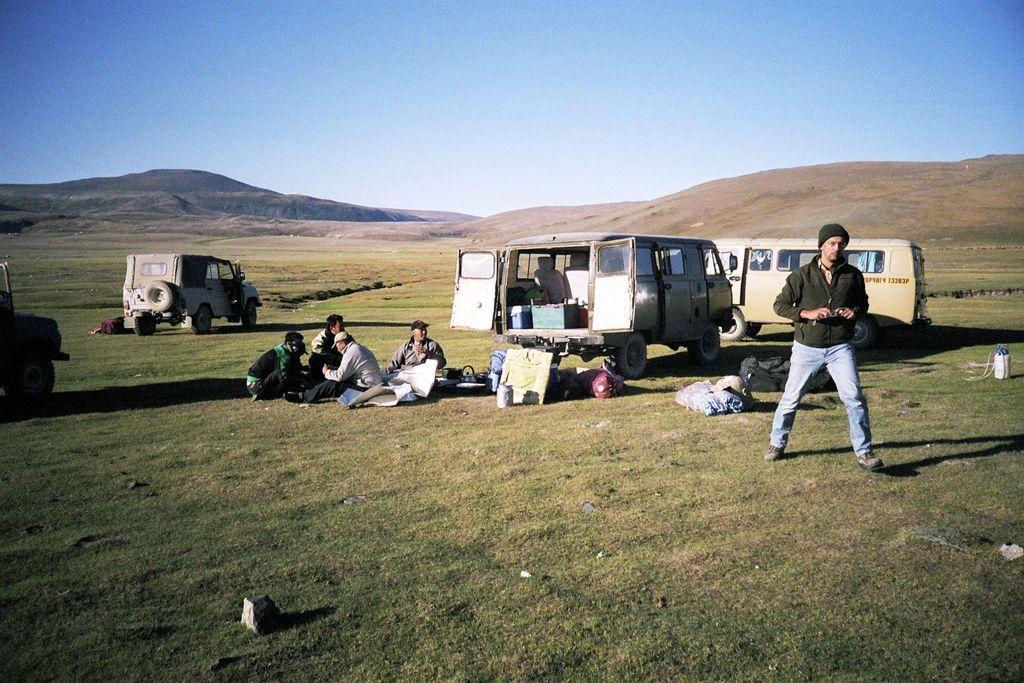In one or two sentences, can you explain what this image depicts? In this image, I can see a group of people sitting and a person standing. There are vehicles, bags and few other objects on the grass. In the background, I can see the hills and the sky, 